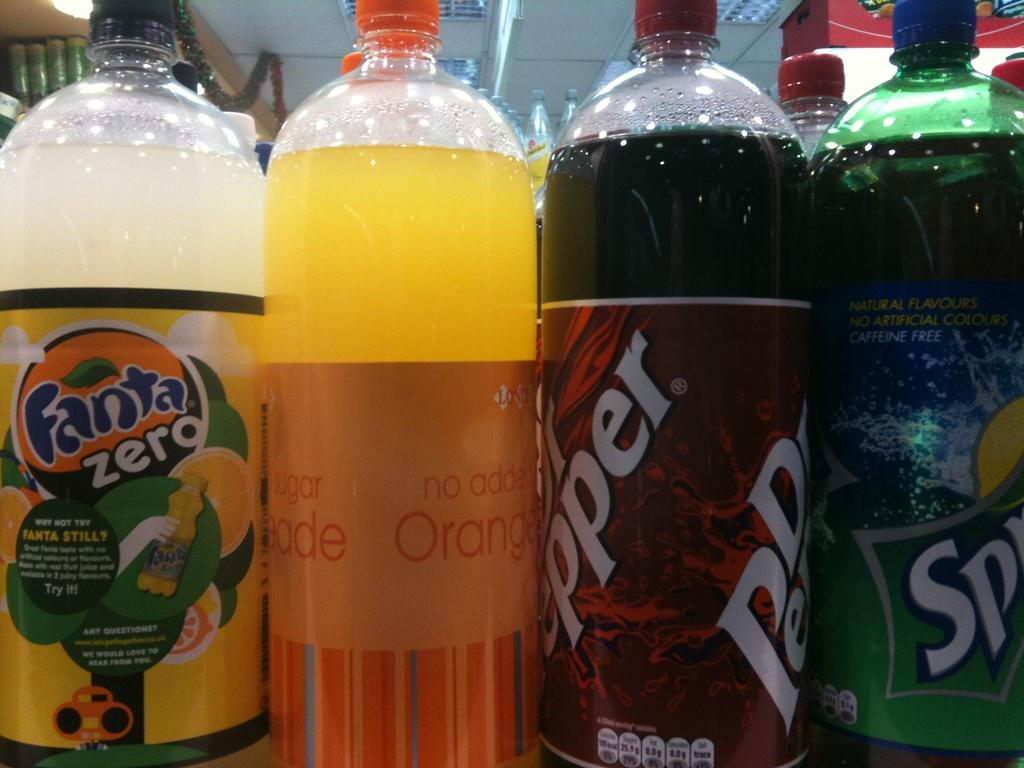<image>
Offer a succinct explanation of the picture presented. bottles of soda lined up with one labeled as 'dr pepper' 